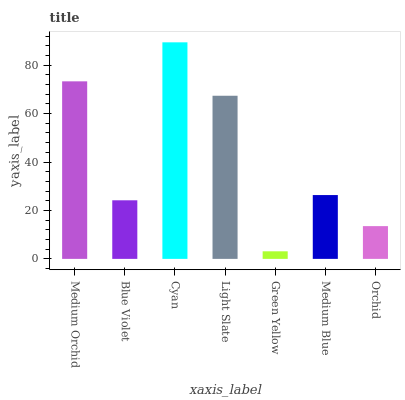Is Green Yellow the minimum?
Answer yes or no. Yes. Is Cyan the maximum?
Answer yes or no. Yes. Is Blue Violet the minimum?
Answer yes or no. No. Is Blue Violet the maximum?
Answer yes or no. No. Is Medium Orchid greater than Blue Violet?
Answer yes or no. Yes. Is Blue Violet less than Medium Orchid?
Answer yes or no. Yes. Is Blue Violet greater than Medium Orchid?
Answer yes or no. No. Is Medium Orchid less than Blue Violet?
Answer yes or no. No. Is Medium Blue the high median?
Answer yes or no. Yes. Is Medium Blue the low median?
Answer yes or no. Yes. Is Medium Orchid the high median?
Answer yes or no. No. Is Orchid the low median?
Answer yes or no. No. 